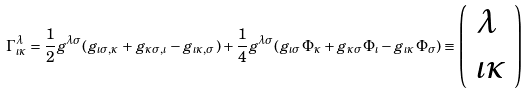Convert formula to latex. <formula><loc_0><loc_0><loc_500><loc_500>\Gamma ^ { \lambda } _ { \iota \kappa } = \frac { 1 } { 2 } g ^ { \lambda \sigma } ( g _ { \iota \sigma , \kappa } + g _ { \kappa \sigma , \iota } - g _ { \iota \kappa , \sigma } ) + \frac { 1 } { 4 } g ^ { \lambda \sigma } ( g _ { \iota \sigma } \Phi _ { \kappa } + g _ { \kappa \sigma } \Phi _ { \iota } - g _ { \iota \kappa } \Phi _ { \sigma } ) \equiv \left ( \begin{array} { l l } \lambda \\ \iota \kappa \end{array} \right )</formula> 